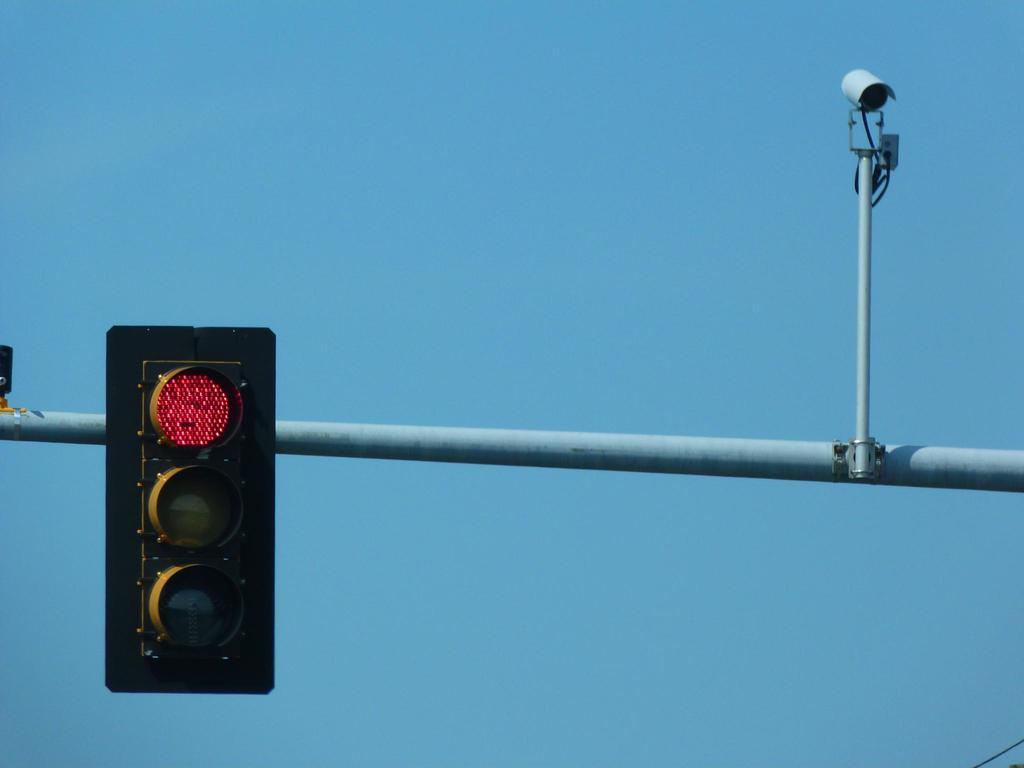What is the main object in the center of the image? There is a rod in the center of the center of the image. What is attached to the rod? Traffic lights and a CCTV camera are attached to the rod. What can be seen in the background of the image? The sky is visible in the background of the image. What type of throne is visible in the image? There is no throne present in the image. How much dust can be seen on the CCTV camera in the image? The image does not provide information about the amount of dust on the CCTV camera, as it is not mentioned in the facts. 